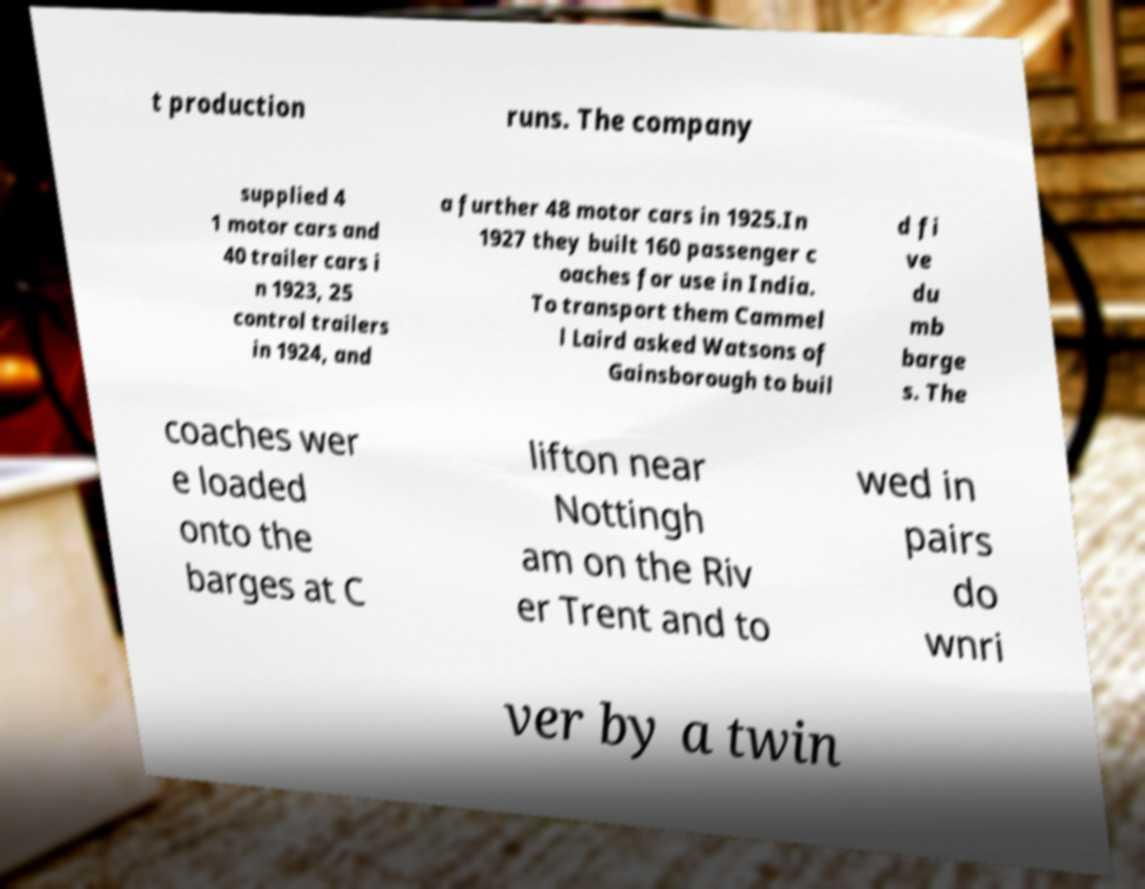Please read and relay the text visible in this image. What does it say? t production runs. The company supplied 4 1 motor cars and 40 trailer cars i n 1923, 25 control trailers in 1924, and a further 48 motor cars in 1925.In 1927 they built 160 passenger c oaches for use in India. To transport them Cammel l Laird asked Watsons of Gainsborough to buil d fi ve du mb barge s. The coaches wer e loaded onto the barges at C lifton near Nottingh am on the Riv er Trent and to wed in pairs do wnri ver by a twin 